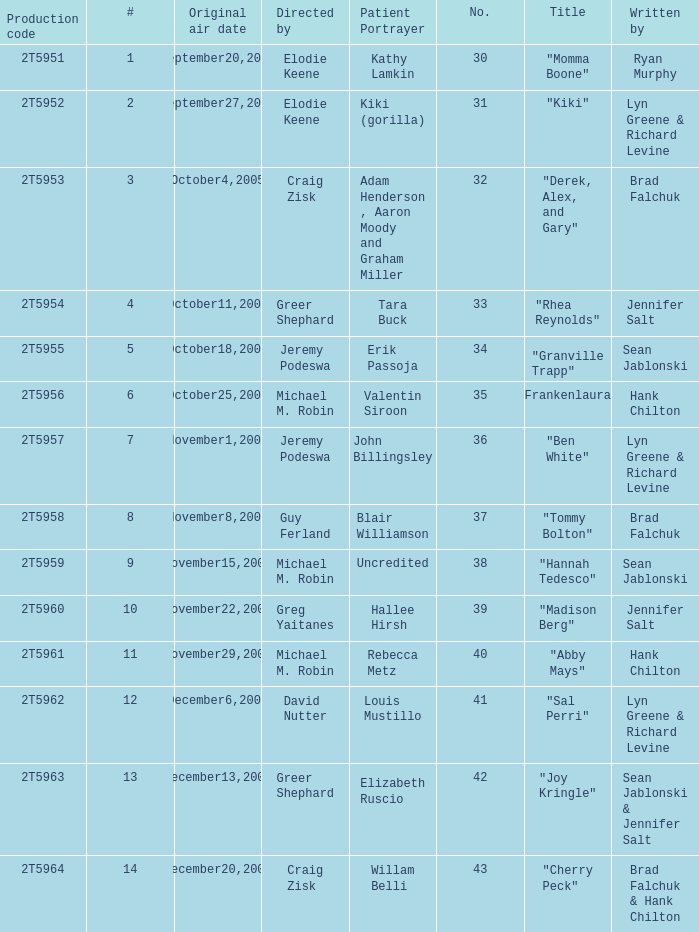What is the total number of patient portayers for the episode directed by Craig Zisk and written by Brad Falchuk? 1.0. 